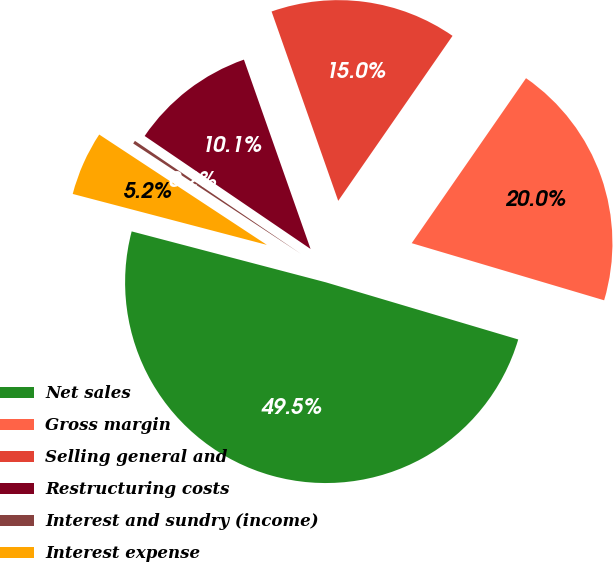<chart> <loc_0><loc_0><loc_500><loc_500><pie_chart><fcel>Net sales<fcel>Gross margin<fcel>Selling general and<fcel>Restructuring costs<fcel>Interest and sundry (income)<fcel>Interest expense<nl><fcel>49.49%<fcel>19.95%<fcel>15.03%<fcel>10.1%<fcel>0.25%<fcel>5.18%<nl></chart> 